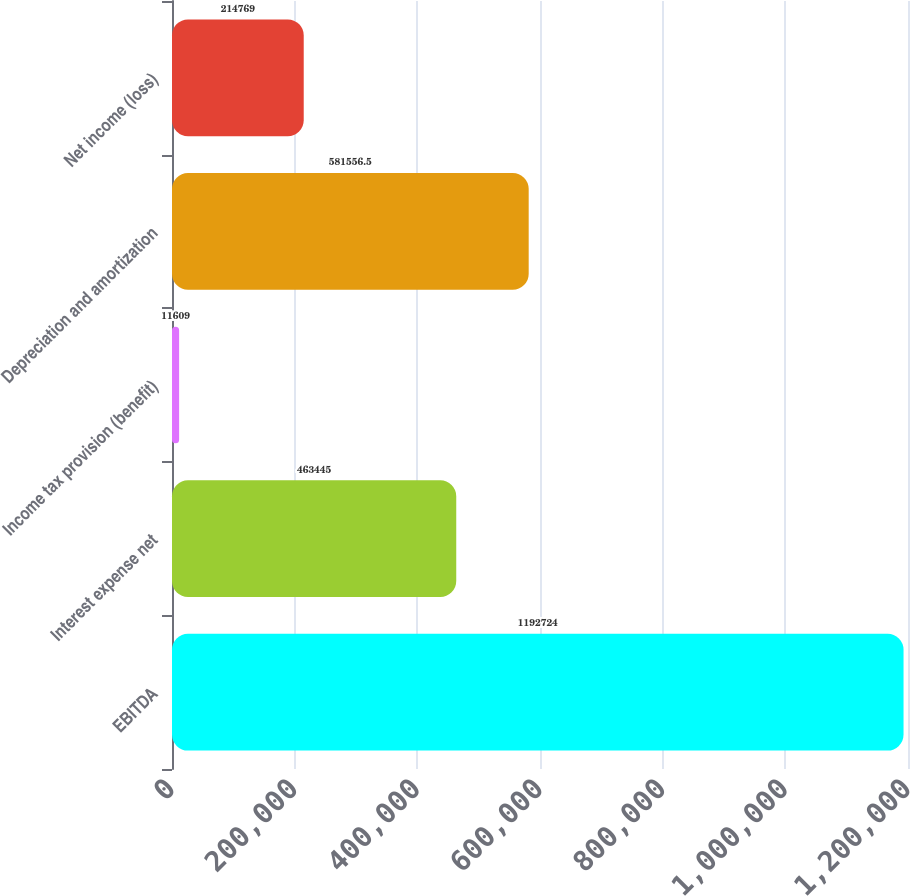Convert chart. <chart><loc_0><loc_0><loc_500><loc_500><bar_chart><fcel>EBITDA<fcel>Interest expense net<fcel>Income tax provision (benefit)<fcel>Depreciation and amortization<fcel>Net income (loss)<nl><fcel>1.19272e+06<fcel>463445<fcel>11609<fcel>581556<fcel>214769<nl></chart> 